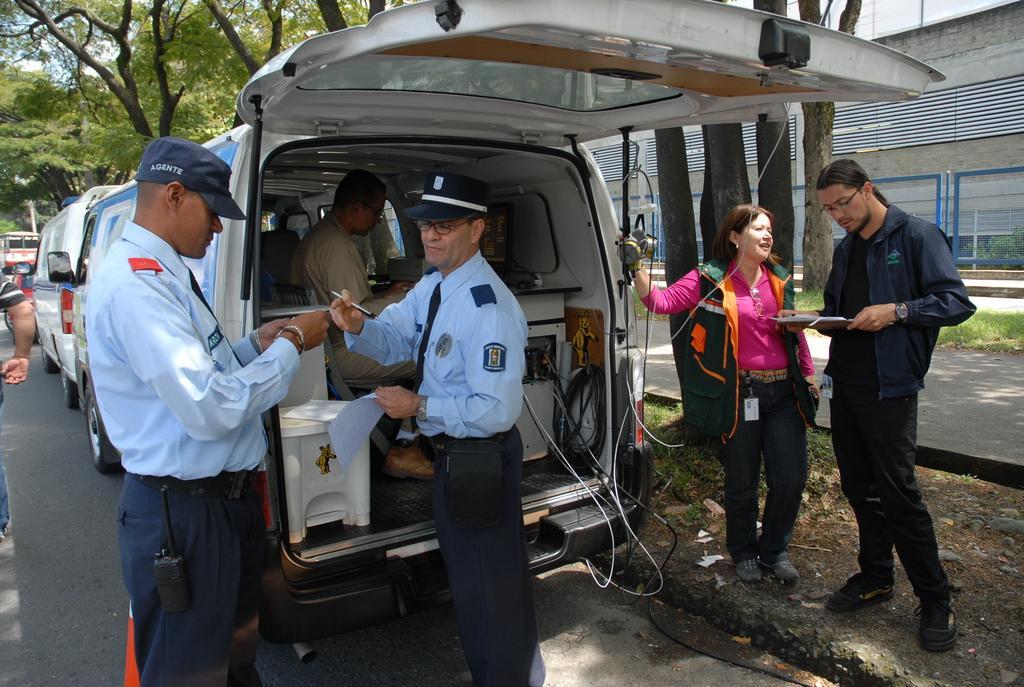Can you describe this image briefly? This is the picture on the road. There are group of people standing on the road. There are many vehicles on the road. There is a person sitting in the vehicle. At the back there are trees and a fence and a building. 